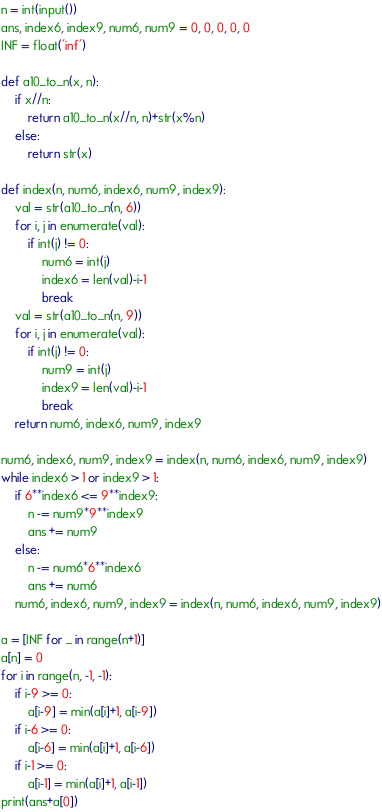Convert code to text. <code><loc_0><loc_0><loc_500><loc_500><_Python_>n = int(input())
ans, index6, index9, num6, num9 = 0, 0, 0, 0, 0
INF = float('inf')

def a10_to_n(x, n):
    if x//n:
        return a10_to_n(x//n, n)+str(x%n)
    else:
        return str(x)

def index(n, num6, index6, num9, index9):
    val = str(a10_to_n(n, 6))
    for i, j in enumerate(val):
        if int(j) != 0:
            num6 = int(j)
            index6 = len(val)-i-1
            break
    val = str(a10_to_n(n, 9))
    for i, j in enumerate(val):
        if int(j) != 0:
            num9 = int(j)
            index9 = len(val)-i-1
            break
    return num6, index6, num9, index9

num6, index6, num9, index9 = index(n, num6, index6, num9, index9)
while index6 > 1 or index9 > 1:
    if 6**index6 <= 9**index9:
        n -= num9*9**index9
        ans += num9
    else:
        n -= num6*6**index6
        ans += num6
    num6, index6, num9, index9 = index(n, num6, index6, num9, index9)
    
a = [INF for _ in range(n+1)]
a[n] = 0
for i in range(n, -1, -1):
    if i-9 >= 0:
        a[i-9] = min(a[i]+1, a[i-9])
    if i-6 >= 0:
        a[i-6] = min(a[i]+1, a[i-6])
    if i-1 >= 0:
        a[i-1] = min(a[i]+1, a[i-1])
print(ans+a[0])
</code> 